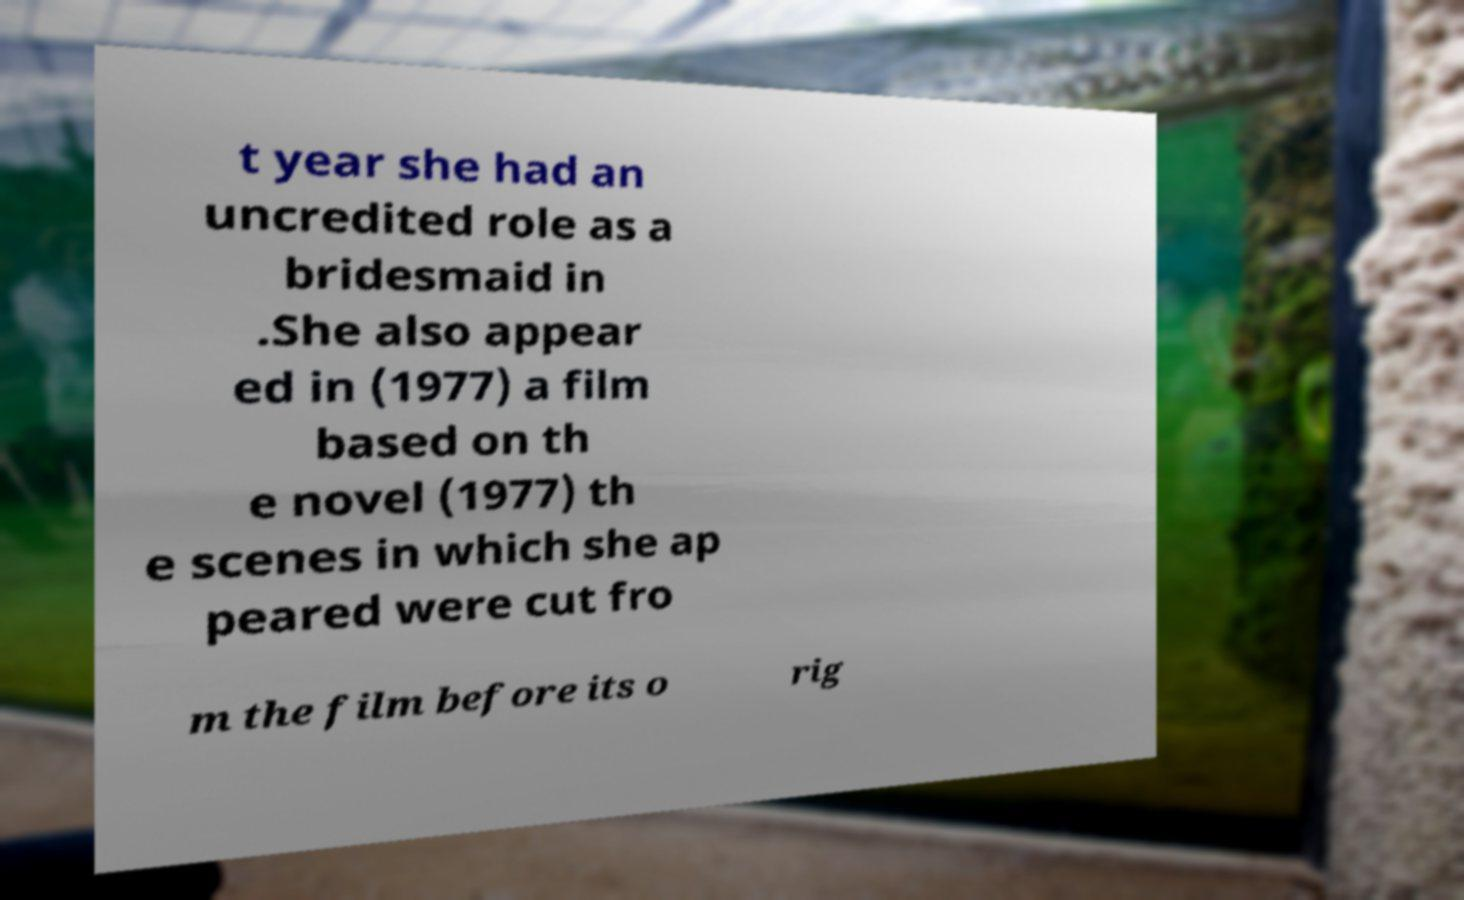Can you read and provide the text displayed in the image?This photo seems to have some interesting text. Can you extract and type it out for me? t year she had an uncredited role as a bridesmaid in .She also appear ed in (1977) a film based on th e novel (1977) th e scenes in which she ap peared were cut fro m the film before its o rig 